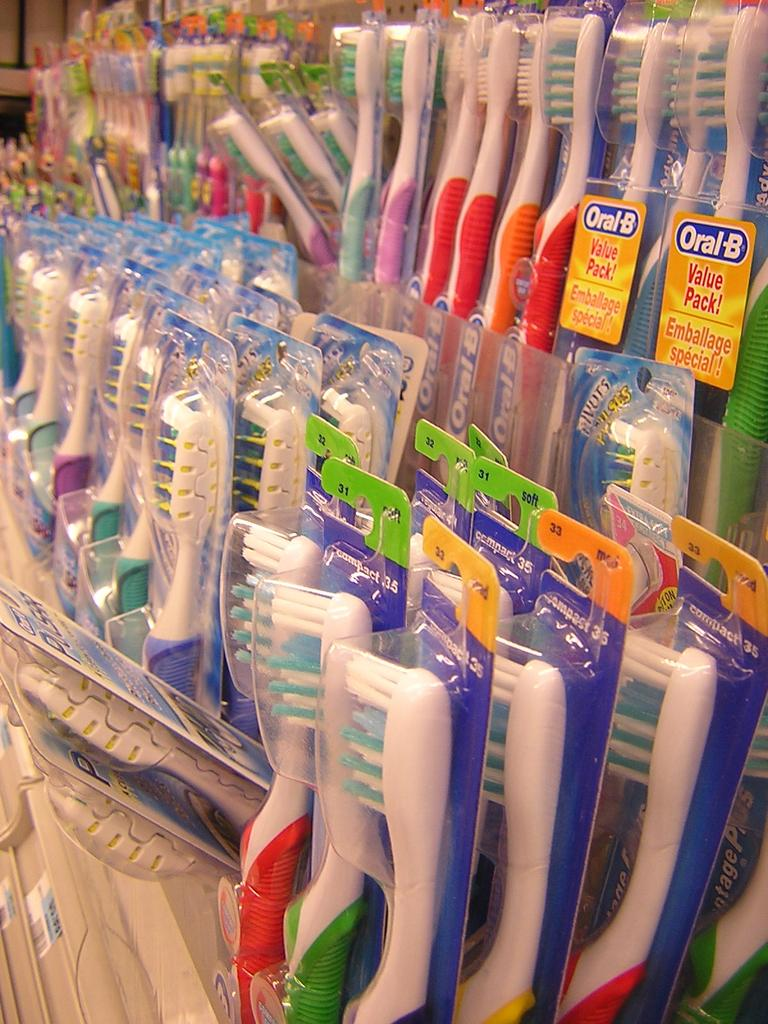What type of products are visible in the image? There are many packaged toothbrushes in the image. Can you describe the packaging of the toothbrushes? The toothbrushes are packaged individually. How many toothbrushes can be seen in the image? There are many toothbrushes visible in the image, but a specific count is not provided. What type of harmony can be observed between the toothbrushes in the image? There is no harmony present in the image, as it only features packaged toothbrushes. 